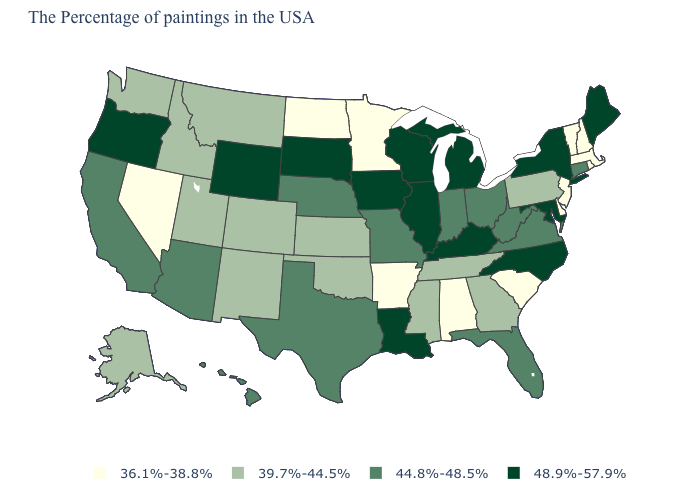What is the lowest value in the USA?
Be succinct. 36.1%-38.8%. Among the states that border Indiana , does Kentucky have the highest value?
Answer briefly. Yes. What is the value of Virginia?
Keep it brief. 44.8%-48.5%. Name the states that have a value in the range 39.7%-44.5%?
Write a very short answer. Pennsylvania, Georgia, Tennessee, Mississippi, Kansas, Oklahoma, Colorado, New Mexico, Utah, Montana, Idaho, Washington, Alaska. Among the states that border New Mexico , does Utah have the highest value?
Be succinct. No. Name the states that have a value in the range 44.8%-48.5%?
Be succinct. Connecticut, Virginia, West Virginia, Ohio, Florida, Indiana, Missouri, Nebraska, Texas, Arizona, California, Hawaii. How many symbols are there in the legend?
Give a very brief answer. 4. Among the states that border Maine , which have the highest value?
Short answer required. New Hampshire. What is the highest value in the MidWest ?
Give a very brief answer. 48.9%-57.9%. What is the value of North Carolina?
Short answer required. 48.9%-57.9%. Name the states that have a value in the range 36.1%-38.8%?
Short answer required. Massachusetts, Rhode Island, New Hampshire, Vermont, New Jersey, Delaware, South Carolina, Alabama, Arkansas, Minnesota, North Dakota, Nevada. What is the value of Kentucky?
Keep it brief. 48.9%-57.9%. Name the states that have a value in the range 48.9%-57.9%?
Give a very brief answer. Maine, New York, Maryland, North Carolina, Michigan, Kentucky, Wisconsin, Illinois, Louisiana, Iowa, South Dakota, Wyoming, Oregon. Does the first symbol in the legend represent the smallest category?
Give a very brief answer. Yes. What is the value of Iowa?
Concise answer only. 48.9%-57.9%. 